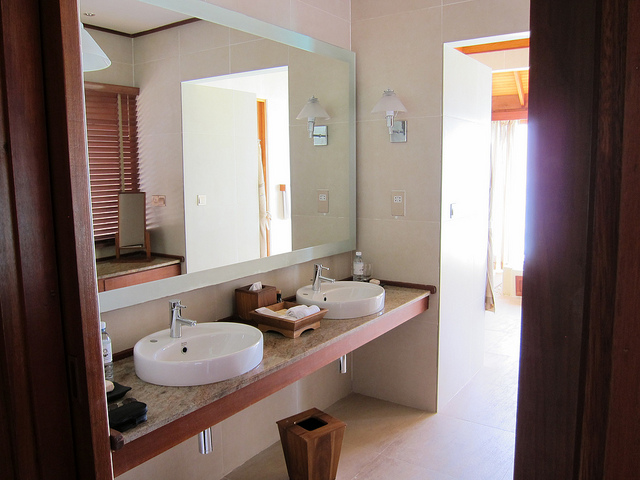What type of bathroom is depicted in the image? A public restroom or a private home bathroom? The bathroom depicted is clearly a private home bathroom. This can be inferred from the cozy and personalized setup that includes dual sinks, a shared vanity, and decorative elements, which are not commonly found in the more functional design of public restrooms. 